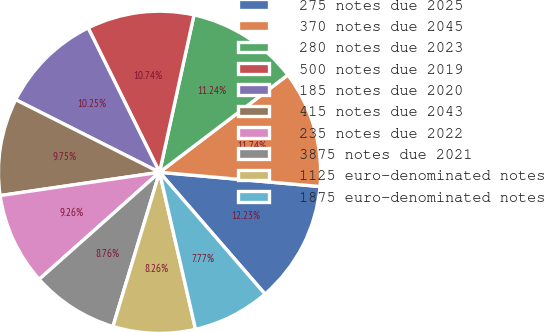<chart> <loc_0><loc_0><loc_500><loc_500><pie_chart><fcel>275 notes due 2025<fcel>370 notes due 2045<fcel>280 notes due 2023<fcel>500 notes due 2019<fcel>185 notes due 2020<fcel>415 notes due 2043<fcel>235 notes due 2022<fcel>3875 notes due 2021<fcel>1125 euro-denominated notes<fcel>1875 euro-denominated notes<nl><fcel>12.23%<fcel>11.74%<fcel>11.24%<fcel>10.74%<fcel>10.25%<fcel>9.75%<fcel>9.26%<fcel>8.76%<fcel>8.26%<fcel>7.77%<nl></chart> 